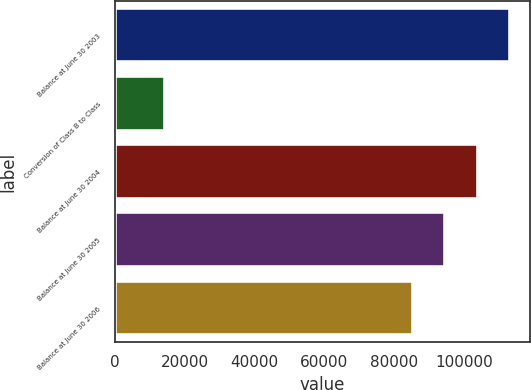<chart> <loc_0><loc_0><loc_500><loc_500><bar_chart><fcel>Balance at June 30 2003<fcel>Conversion of Class B to Class<fcel>Balance at June 30 2004<fcel>Balance at June 30 2005<fcel>Balance at June 30 2006<nl><fcel>113210<fcel>14449.6<fcel>103908<fcel>94607.2<fcel>85305.9<nl></chart> 